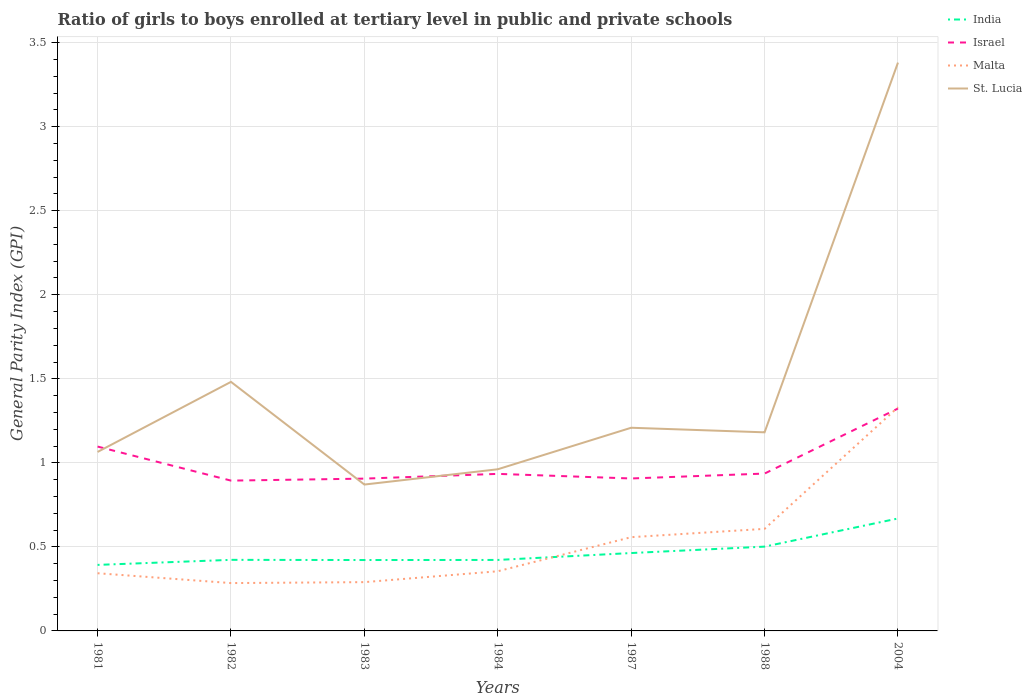How many different coloured lines are there?
Give a very brief answer. 4. Does the line corresponding to India intersect with the line corresponding to Malta?
Keep it short and to the point. Yes. Is the number of lines equal to the number of legend labels?
Your answer should be very brief. Yes. Across all years, what is the maximum general parity index in India?
Your answer should be very brief. 0.39. What is the total general parity index in Malta in the graph?
Offer a very short reply. -0.98. What is the difference between the highest and the second highest general parity index in Israel?
Provide a short and direct response. 0.43. Is the general parity index in Malta strictly greater than the general parity index in Israel over the years?
Your answer should be very brief. No. How many years are there in the graph?
Offer a very short reply. 7. What is the difference between two consecutive major ticks on the Y-axis?
Your answer should be compact. 0.5. Are the values on the major ticks of Y-axis written in scientific E-notation?
Offer a terse response. No. Does the graph contain any zero values?
Your response must be concise. No. Does the graph contain grids?
Give a very brief answer. Yes. What is the title of the graph?
Your response must be concise. Ratio of girls to boys enrolled at tertiary level in public and private schools. Does "Mexico" appear as one of the legend labels in the graph?
Ensure brevity in your answer.  No. What is the label or title of the Y-axis?
Provide a short and direct response. General Parity Index (GPI). What is the General Parity Index (GPI) of India in 1981?
Offer a terse response. 0.39. What is the General Parity Index (GPI) in Israel in 1981?
Your response must be concise. 1.1. What is the General Parity Index (GPI) in Malta in 1981?
Make the answer very short. 0.34. What is the General Parity Index (GPI) in St. Lucia in 1981?
Provide a succinct answer. 1.06. What is the General Parity Index (GPI) in India in 1982?
Provide a succinct answer. 0.42. What is the General Parity Index (GPI) of Israel in 1982?
Give a very brief answer. 0.89. What is the General Parity Index (GPI) in Malta in 1982?
Ensure brevity in your answer.  0.28. What is the General Parity Index (GPI) of St. Lucia in 1982?
Your answer should be very brief. 1.48. What is the General Parity Index (GPI) of India in 1983?
Offer a terse response. 0.42. What is the General Parity Index (GPI) of Israel in 1983?
Your response must be concise. 0.91. What is the General Parity Index (GPI) of Malta in 1983?
Provide a short and direct response. 0.29. What is the General Parity Index (GPI) of St. Lucia in 1983?
Offer a terse response. 0.87. What is the General Parity Index (GPI) in India in 1984?
Give a very brief answer. 0.42. What is the General Parity Index (GPI) in Israel in 1984?
Your answer should be compact. 0.93. What is the General Parity Index (GPI) in Malta in 1984?
Your answer should be compact. 0.35. What is the General Parity Index (GPI) of St. Lucia in 1984?
Keep it short and to the point. 0.96. What is the General Parity Index (GPI) in India in 1987?
Your answer should be very brief. 0.46. What is the General Parity Index (GPI) of Israel in 1987?
Make the answer very short. 0.91. What is the General Parity Index (GPI) of Malta in 1987?
Give a very brief answer. 0.56. What is the General Parity Index (GPI) in St. Lucia in 1987?
Your answer should be very brief. 1.21. What is the General Parity Index (GPI) of India in 1988?
Your response must be concise. 0.5. What is the General Parity Index (GPI) in Israel in 1988?
Your answer should be very brief. 0.94. What is the General Parity Index (GPI) in Malta in 1988?
Give a very brief answer. 0.61. What is the General Parity Index (GPI) in St. Lucia in 1988?
Make the answer very short. 1.18. What is the General Parity Index (GPI) of India in 2004?
Make the answer very short. 0.67. What is the General Parity Index (GPI) of Israel in 2004?
Offer a terse response. 1.32. What is the General Parity Index (GPI) of Malta in 2004?
Give a very brief answer. 1.33. What is the General Parity Index (GPI) of St. Lucia in 2004?
Offer a terse response. 3.38. Across all years, what is the maximum General Parity Index (GPI) in India?
Offer a very short reply. 0.67. Across all years, what is the maximum General Parity Index (GPI) of Israel?
Your answer should be very brief. 1.32. Across all years, what is the maximum General Parity Index (GPI) of Malta?
Your response must be concise. 1.33. Across all years, what is the maximum General Parity Index (GPI) in St. Lucia?
Offer a very short reply. 3.38. Across all years, what is the minimum General Parity Index (GPI) in India?
Ensure brevity in your answer.  0.39. Across all years, what is the minimum General Parity Index (GPI) in Israel?
Your answer should be very brief. 0.89. Across all years, what is the minimum General Parity Index (GPI) of Malta?
Your response must be concise. 0.28. Across all years, what is the minimum General Parity Index (GPI) of St. Lucia?
Keep it short and to the point. 0.87. What is the total General Parity Index (GPI) of India in the graph?
Offer a very short reply. 3.29. What is the total General Parity Index (GPI) in Israel in the graph?
Offer a terse response. 7. What is the total General Parity Index (GPI) in Malta in the graph?
Your answer should be very brief. 3.77. What is the total General Parity Index (GPI) of St. Lucia in the graph?
Ensure brevity in your answer.  10.15. What is the difference between the General Parity Index (GPI) of India in 1981 and that in 1982?
Offer a terse response. -0.03. What is the difference between the General Parity Index (GPI) in Israel in 1981 and that in 1982?
Provide a succinct answer. 0.2. What is the difference between the General Parity Index (GPI) in Malta in 1981 and that in 1982?
Your answer should be very brief. 0.06. What is the difference between the General Parity Index (GPI) of St. Lucia in 1981 and that in 1982?
Ensure brevity in your answer.  -0.42. What is the difference between the General Parity Index (GPI) in India in 1981 and that in 1983?
Offer a very short reply. -0.03. What is the difference between the General Parity Index (GPI) in Israel in 1981 and that in 1983?
Provide a succinct answer. 0.19. What is the difference between the General Parity Index (GPI) of Malta in 1981 and that in 1983?
Your response must be concise. 0.05. What is the difference between the General Parity Index (GPI) in St. Lucia in 1981 and that in 1983?
Provide a short and direct response. 0.19. What is the difference between the General Parity Index (GPI) in India in 1981 and that in 1984?
Offer a terse response. -0.03. What is the difference between the General Parity Index (GPI) of Israel in 1981 and that in 1984?
Your answer should be compact. 0.16. What is the difference between the General Parity Index (GPI) of Malta in 1981 and that in 1984?
Make the answer very short. -0.01. What is the difference between the General Parity Index (GPI) in St. Lucia in 1981 and that in 1984?
Make the answer very short. 0.1. What is the difference between the General Parity Index (GPI) of India in 1981 and that in 1987?
Offer a very short reply. -0.07. What is the difference between the General Parity Index (GPI) of Israel in 1981 and that in 1987?
Offer a terse response. 0.19. What is the difference between the General Parity Index (GPI) in Malta in 1981 and that in 1987?
Make the answer very short. -0.21. What is the difference between the General Parity Index (GPI) in St. Lucia in 1981 and that in 1987?
Keep it short and to the point. -0.14. What is the difference between the General Parity Index (GPI) of India in 1981 and that in 1988?
Ensure brevity in your answer.  -0.11. What is the difference between the General Parity Index (GPI) in Israel in 1981 and that in 1988?
Make the answer very short. 0.16. What is the difference between the General Parity Index (GPI) of Malta in 1981 and that in 1988?
Provide a short and direct response. -0.26. What is the difference between the General Parity Index (GPI) in St. Lucia in 1981 and that in 1988?
Make the answer very short. -0.12. What is the difference between the General Parity Index (GPI) in India in 1981 and that in 2004?
Give a very brief answer. -0.28. What is the difference between the General Parity Index (GPI) of Israel in 1981 and that in 2004?
Make the answer very short. -0.23. What is the difference between the General Parity Index (GPI) of Malta in 1981 and that in 2004?
Keep it short and to the point. -0.99. What is the difference between the General Parity Index (GPI) of St. Lucia in 1981 and that in 2004?
Ensure brevity in your answer.  -2.32. What is the difference between the General Parity Index (GPI) of India in 1982 and that in 1983?
Offer a terse response. 0. What is the difference between the General Parity Index (GPI) of Israel in 1982 and that in 1983?
Your answer should be very brief. -0.01. What is the difference between the General Parity Index (GPI) of Malta in 1982 and that in 1983?
Provide a succinct answer. -0.01. What is the difference between the General Parity Index (GPI) in St. Lucia in 1982 and that in 1983?
Give a very brief answer. 0.61. What is the difference between the General Parity Index (GPI) of India in 1982 and that in 1984?
Your answer should be compact. 0. What is the difference between the General Parity Index (GPI) in Israel in 1982 and that in 1984?
Provide a short and direct response. -0.04. What is the difference between the General Parity Index (GPI) in Malta in 1982 and that in 1984?
Make the answer very short. -0.07. What is the difference between the General Parity Index (GPI) in St. Lucia in 1982 and that in 1984?
Your answer should be compact. 0.52. What is the difference between the General Parity Index (GPI) in India in 1982 and that in 1987?
Your answer should be very brief. -0.04. What is the difference between the General Parity Index (GPI) in Israel in 1982 and that in 1987?
Provide a short and direct response. -0.01. What is the difference between the General Parity Index (GPI) of Malta in 1982 and that in 1987?
Give a very brief answer. -0.27. What is the difference between the General Parity Index (GPI) of St. Lucia in 1982 and that in 1987?
Your answer should be very brief. 0.27. What is the difference between the General Parity Index (GPI) in India in 1982 and that in 1988?
Your answer should be compact. -0.08. What is the difference between the General Parity Index (GPI) in Israel in 1982 and that in 1988?
Offer a terse response. -0.04. What is the difference between the General Parity Index (GPI) of Malta in 1982 and that in 1988?
Ensure brevity in your answer.  -0.32. What is the difference between the General Parity Index (GPI) in St. Lucia in 1982 and that in 1988?
Keep it short and to the point. 0.3. What is the difference between the General Parity Index (GPI) in India in 1982 and that in 2004?
Give a very brief answer. -0.25. What is the difference between the General Parity Index (GPI) in Israel in 1982 and that in 2004?
Your answer should be very brief. -0.43. What is the difference between the General Parity Index (GPI) of Malta in 1982 and that in 2004?
Your answer should be compact. -1.05. What is the difference between the General Parity Index (GPI) of St. Lucia in 1982 and that in 2004?
Provide a short and direct response. -1.9. What is the difference between the General Parity Index (GPI) in India in 1983 and that in 1984?
Make the answer very short. -0. What is the difference between the General Parity Index (GPI) of Israel in 1983 and that in 1984?
Offer a terse response. -0.03. What is the difference between the General Parity Index (GPI) in Malta in 1983 and that in 1984?
Offer a terse response. -0.06. What is the difference between the General Parity Index (GPI) in St. Lucia in 1983 and that in 1984?
Offer a terse response. -0.09. What is the difference between the General Parity Index (GPI) in India in 1983 and that in 1987?
Your answer should be compact. -0.04. What is the difference between the General Parity Index (GPI) of Israel in 1983 and that in 1987?
Give a very brief answer. -0. What is the difference between the General Parity Index (GPI) in Malta in 1983 and that in 1987?
Make the answer very short. -0.27. What is the difference between the General Parity Index (GPI) of St. Lucia in 1983 and that in 1987?
Your answer should be very brief. -0.34. What is the difference between the General Parity Index (GPI) of India in 1983 and that in 1988?
Make the answer very short. -0.08. What is the difference between the General Parity Index (GPI) of Israel in 1983 and that in 1988?
Provide a short and direct response. -0.03. What is the difference between the General Parity Index (GPI) in Malta in 1983 and that in 1988?
Offer a terse response. -0.32. What is the difference between the General Parity Index (GPI) of St. Lucia in 1983 and that in 1988?
Give a very brief answer. -0.31. What is the difference between the General Parity Index (GPI) of India in 1983 and that in 2004?
Your response must be concise. -0.25. What is the difference between the General Parity Index (GPI) of Israel in 1983 and that in 2004?
Keep it short and to the point. -0.42. What is the difference between the General Parity Index (GPI) of Malta in 1983 and that in 2004?
Ensure brevity in your answer.  -1.04. What is the difference between the General Parity Index (GPI) in St. Lucia in 1983 and that in 2004?
Give a very brief answer. -2.51. What is the difference between the General Parity Index (GPI) of India in 1984 and that in 1987?
Ensure brevity in your answer.  -0.04. What is the difference between the General Parity Index (GPI) of Israel in 1984 and that in 1987?
Your answer should be compact. 0.03. What is the difference between the General Parity Index (GPI) in Malta in 1984 and that in 1987?
Your response must be concise. -0.2. What is the difference between the General Parity Index (GPI) in St. Lucia in 1984 and that in 1987?
Give a very brief answer. -0.25. What is the difference between the General Parity Index (GPI) of India in 1984 and that in 1988?
Your answer should be compact. -0.08. What is the difference between the General Parity Index (GPI) in Israel in 1984 and that in 1988?
Provide a succinct answer. -0. What is the difference between the General Parity Index (GPI) in Malta in 1984 and that in 1988?
Ensure brevity in your answer.  -0.25. What is the difference between the General Parity Index (GPI) in St. Lucia in 1984 and that in 1988?
Make the answer very short. -0.22. What is the difference between the General Parity Index (GPI) in India in 1984 and that in 2004?
Keep it short and to the point. -0.25. What is the difference between the General Parity Index (GPI) of Israel in 1984 and that in 2004?
Offer a very short reply. -0.39. What is the difference between the General Parity Index (GPI) in Malta in 1984 and that in 2004?
Your answer should be compact. -0.98. What is the difference between the General Parity Index (GPI) of St. Lucia in 1984 and that in 2004?
Give a very brief answer. -2.42. What is the difference between the General Parity Index (GPI) in India in 1987 and that in 1988?
Your response must be concise. -0.04. What is the difference between the General Parity Index (GPI) in Israel in 1987 and that in 1988?
Provide a succinct answer. -0.03. What is the difference between the General Parity Index (GPI) in Malta in 1987 and that in 1988?
Provide a succinct answer. -0.05. What is the difference between the General Parity Index (GPI) in St. Lucia in 1987 and that in 1988?
Offer a terse response. 0.03. What is the difference between the General Parity Index (GPI) in India in 1987 and that in 2004?
Your answer should be very brief. -0.21. What is the difference between the General Parity Index (GPI) of Israel in 1987 and that in 2004?
Offer a terse response. -0.42. What is the difference between the General Parity Index (GPI) of Malta in 1987 and that in 2004?
Ensure brevity in your answer.  -0.77. What is the difference between the General Parity Index (GPI) of St. Lucia in 1987 and that in 2004?
Your answer should be compact. -2.17. What is the difference between the General Parity Index (GPI) of India in 1988 and that in 2004?
Give a very brief answer. -0.17. What is the difference between the General Parity Index (GPI) of Israel in 1988 and that in 2004?
Your response must be concise. -0.39. What is the difference between the General Parity Index (GPI) of Malta in 1988 and that in 2004?
Offer a very short reply. -0.72. What is the difference between the General Parity Index (GPI) of St. Lucia in 1988 and that in 2004?
Ensure brevity in your answer.  -2.2. What is the difference between the General Parity Index (GPI) of India in 1981 and the General Parity Index (GPI) of Israel in 1982?
Your answer should be very brief. -0.5. What is the difference between the General Parity Index (GPI) of India in 1981 and the General Parity Index (GPI) of Malta in 1982?
Offer a very short reply. 0.11. What is the difference between the General Parity Index (GPI) of India in 1981 and the General Parity Index (GPI) of St. Lucia in 1982?
Offer a very short reply. -1.09. What is the difference between the General Parity Index (GPI) of Israel in 1981 and the General Parity Index (GPI) of Malta in 1982?
Your response must be concise. 0.81. What is the difference between the General Parity Index (GPI) of Israel in 1981 and the General Parity Index (GPI) of St. Lucia in 1982?
Your response must be concise. -0.38. What is the difference between the General Parity Index (GPI) in Malta in 1981 and the General Parity Index (GPI) in St. Lucia in 1982?
Your answer should be very brief. -1.14. What is the difference between the General Parity Index (GPI) in India in 1981 and the General Parity Index (GPI) in Israel in 1983?
Your answer should be very brief. -0.51. What is the difference between the General Parity Index (GPI) in India in 1981 and the General Parity Index (GPI) in Malta in 1983?
Provide a short and direct response. 0.1. What is the difference between the General Parity Index (GPI) in India in 1981 and the General Parity Index (GPI) in St. Lucia in 1983?
Provide a short and direct response. -0.48. What is the difference between the General Parity Index (GPI) in Israel in 1981 and the General Parity Index (GPI) in Malta in 1983?
Keep it short and to the point. 0.81. What is the difference between the General Parity Index (GPI) in Israel in 1981 and the General Parity Index (GPI) in St. Lucia in 1983?
Your answer should be compact. 0.23. What is the difference between the General Parity Index (GPI) in Malta in 1981 and the General Parity Index (GPI) in St. Lucia in 1983?
Your answer should be compact. -0.53. What is the difference between the General Parity Index (GPI) of India in 1981 and the General Parity Index (GPI) of Israel in 1984?
Provide a succinct answer. -0.54. What is the difference between the General Parity Index (GPI) of India in 1981 and the General Parity Index (GPI) of Malta in 1984?
Provide a short and direct response. 0.04. What is the difference between the General Parity Index (GPI) of India in 1981 and the General Parity Index (GPI) of St. Lucia in 1984?
Provide a short and direct response. -0.57. What is the difference between the General Parity Index (GPI) of Israel in 1981 and the General Parity Index (GPI) of Malta in 1984?
Make the answer very short. 0.74. What is the difference between the General Parity Index (GPI) of Israel in 1981 and the General Parity Index (GPI) of St. Lucia in 1984?
Offer a terse response. 0.14. What is the difference between the General Parity Index (GPI) of Malta in 1981 and the General Parity Index (GPI) of St. Lucia in 1984?
Offer a very short reply. -0.62. What is the difference between the General Parity Index (GPI) in India in 1981 and the General Parity Index (GPI) in Israel in 1987?
Your answer should be compact. -0.51. What is the difference between the General Parity Index (GPI) of India in 1981 and the General Parity Index (GPI) of Malta in 1987?
Your answer should be very brief. -0.17. What is the difference between the General Parity Index (GPI) in India in 1981 and the General Parity Index (GPI) in St. Lucia in 1987?
Keep it short and to the point. -0.82. What is the difference between the General Parity Index (GPI) in Israel in 1981 and the General Parity Index (GPI) in Malta in 1987?
Provide a short and direct response. 0.54. What is the difference between the General Parity Index (GPI) of Israel in 1981 and the General Parity Index (GPI) of St. Lucia in 1987?
Your answer should be very brief. -0.11. What is the difference between the General Parity Index (GPI) of Malta in 1981 and the General Parity Index (GPI) of St. Lucia in 1987?
Your answer should be compact. -0.87. What is the difference between the General Parity Index (GPI) of India in 1981 and the General Parity Index (GPI) of Israel in 1988?
Offer a terse response. -0.54. What is the difference between the General Parity Index (GPI) in India in 1981 and the General Parity Index (GPI) in Malta in 1988?
Your answer should be very brief. -0.21. What is the difference between the General Parity Index (GPI) of India in 1981 and the General Parity Index (GPI) of St. Lucia in 1988?
Make the answer very short. -0.79. What is the difference between the General Parity Index (GPI) in Israel in 1981 and the General Parity Index (GPI) in Malta in 1988?
Your answer should be very brief. 0.49. What is the difference between the General Parity Index (GPI) in Israel in 1981 and the General Parity Index (GPI) in St. Lucia in 1988?
Make the answer very short. -0.08. What is the difference between the General Parity Index (GPI) of Malta in 1981 and the General Parity Index (GPI) of St. Lucia in 1988?
Keep it short and to the point. -0.84. What is the difference between the General Parity Index (GPI) of India in 1981 and the General Parity Index (GPI) of Israel in 2004?
Keep it short and to the point. -0.93. What is the difference between the General Parity Index (GPI) in India in 1981 and the General Parity Index (GPI) in Malta in 2004?
Make the answer very short. -0.94. What is the difference between the General Parity Index (GPI) in India in 1981 and the General Parity Index (GPI) in St. Lucia in 2004?
Provide a short and direct response. -2.99. What is the difference between the General Parity Index (GPI) of Israel in 1981 and the General Parity Index (GPI) of Malta in 2004?
Make the answer very short. -0.23. What is the difference between the General Parity Index (GPI) of Israel in 1981 and the General Parity Index (GPI) of St. Lucia in 2004?
Your answer should be compact. -2.28. What is the difference between the General Parity Index (GPI) in Malta in 1981 and the General Parity Index (GPI) in St. Lucia in 2004?
Offer a terse response. -3.04. What is the difference between the General Parity Index (GPI) in India in 1982 and the General Parity Index (GPI) in Israel in 1983?
Give a very brief answer. -0.48. What is the difference between the General Parity Index (GPI) in India in 1982 and the General Parity Index (GPI) in Malta in 1983?
Make the answer very short. 0.13. What is the difference between the General Parity Index (GPI) of India in 1982 and the General Parity Index (GPI) of St. Lucia in 1983?
Provide a succinct answer. -0.45. What is the difference between the General Parity Index (GPI) of Israel in 1982 and the General Parity Index (GPI) of Malta in 1983?
Your response must be concise. 0.6. What is the difference between the General Parity Index (GPI) in Israel in 1982 and the General Parity Index (GPI) in St. Lucia in 1983?
Provide a short and direct response. 0.02. What is the difference between the General Parity Index (GPI) in Malta in 1982 and the General Parity Index (GPI) in St. Lucia in 1983?
Provide a short and direct response. -0.59. What is the difference between the General Parity Index (GPI) of India in 1982 and the General Parity Index (GPI) of Israel in 1984?
Make the answer very short. -0.51. What is the difference between the General Parity Index (GPI) of India in 1982 and the General Parity Index (GPI) of Malta in 1984?
Keep it short and to the point. 0.07. What is the difference between the General Parity Index (GPI) of India in 1982 and the General Parity Index (GPI) of St. Lucia in 1984?
Ensure brevity in your answer.  -0.54. What is the difference between the General Parity Index (GPI) of Israel in 1982 and the General Parity Index (GPI) of Malta in 1984?
Keep it short and to the point. 0.54. What is the difference between the General Parity Index (GPI) in Israel in 1982 and the General Parity Index (GPI) in St. Lucia in 1984?
Provide a short and direct response. -0.07. What is the difference between the General Parity Index (GPI) in Malta in 1982 and the General Parity Index (GPI) in St. Lucia in 1984?
Keep it short and to the point. -0.68. What is the difference between the General Parity Index (GPI) in India in 1982 and the General Parity Index (GPI) in Israel in 1987?
Ensure brevity in your answer.  -0.48. What is the difference between the General Parity Index (GPI) of India in 1982 and the General Parity Index (GPI) of Malta in 1987?
Provide a succinct answer. -0.13. What is the difference between the General Parity Index (GPI) in India in 1982 and the General Parity Index (GPI) in St. Lucia in 1987?
Ensure brevity in your answer.  -0.79. What is the difference between the General Parity Index (GPI) in Israel in 1982 and the General Parity Index (GPI) in Malta in 1987?
Offer a terse response. 0.34. What is the difference between the General Parity Index (GPI) in Israel in 1982 and the General Parity Index (GPI) in St. Lucia in 1987?
Give a very brief answer. -0.31. What is the difference between the General Parity Index (GPI) in Malta in 1982 and the General Parity Index (GPI) in St. Lucia in 1987?
Your answer should be very brief. -0.92. What is the difference between the General Parity Index (GPI) in India in 1982 and the General Parity Index (GPI) in Israel in 1988?
Give a very brief answer. -0.51. What is the difference between the General Parity Index (GPI) in India in 1982 and the General Parity Index (GPI) in Malta in 1988?
Provide a short and direct response. -0.18. What is the difference between the General Parity Index (GPI) of India in 1982 and the General Parity Index (GPI) of St. Lucia in 1988?
Provide a succinct answer. -0.76. What is the difference between the General Parity Index (GPI) in Israel in 1982 and the General Parity Index (GPI) in Malta in 1988?
Give a very brief answer. 0.29. What is the difference between the General Parity Index (GPI) of Israel in 1982 and the General Parity Index (GPI) of St. Lucia in 1988?
Provide a succinct answer. -0.29. What is the difference between the General Parity Index (GPI) in Malta in 1982 and the General Parity Index (GPI) in St. Lucia in 1988?
Keep it short and to the point. -0.9. What is the difference between the General Parity Index (GPI) in India in 1982 and the General Parity Index (GPI) in Israel in 2004?
Give a very brief answer. -0.9. What is the difference between the General Parity Index (GPI) of India in 1982 and the General Parity Index (GPI) of Malta in 2004?
Provide a succinct answer. -0.91. What is the difference between the General Parity Index (GPI) in India in 1982 and the General Parity Index (GPI) in St. Lucia in 2004?
Give a very brief answer. -2.96. What is the difference between the General Parity Index (GPI) in Israel in 1982 and the General Parity Index (GPI) in Malta in 2004?
Provide a succinct answer. -0.44. What is the difference between the General Parity Index (GPI) of Israel in 1982 and the General Parity Index (GPI) of St. Lucia in 2004?
Provide a short and direct response. -2.49. What is the difference between the General Parity Index (GPI) of Malta in 1982 and the General Parity Index (GPI) of St. Lucia in 2004?
Ensure brevity in your answer.  -3.1. What is the difference between the General Parity Index (GPI) of India in 1983 and the General Parity Index (GPI) of Israel in 1984?
Provide a succinct answer. -0.51. What is the difference between the General Parity Index (GPI) of India in 1983 and the General Parity Index (GPI) of Malta in 1984?
Offer a terse response. 0.07. What is the difference between the General Parity Index (GPI) in India in 1983 and the General Parity Index (GPI) in St. Lucia in 1984?
Ensure brevity in your answer.  -0.54. What is the difference between the General Parity Index (GPI) in Israel in 1983 and the General Parity Index (GPI) in Malta in 1984?
Give a very brief answer. 0.55. What is the difference between the General Parity Index (GPI) of Israel in 1983 and the General Parity Index (GPI) of St. Lucia in 1984?
Ensure brevity in your answer.  -0.06. What is the difference between the General Parity Index (GPI) of Malta in 1983 and the General Parity Index (GPI) of St. Lucia in 1984?
Your response must be concise. -0.67. What is the difference between the General Parity Index (GPI) in India in 1983 and the General Parity Index (GPI) in Israel in 1987?
Provide a short and direct response. -0.49. What is the difference between the General Parity Index (GPI) in India in 1983 and the General Parity Index (GPI) in Malta in 1987?
Offer a very short reply. -0.14. What is the difference between the General Parity Index (GPI) of India in 1983 and the General Parity Index (GPI) of St. Lucia in 1987?
Offer a very short reply. -0.79. What is the difference between the General Parity Index (GPI) of Israel in 1983 and the General Parity Index (GPI) of Malta in 1987?
Offer a terse response. 0.35. What is the difference between the General Parity Index (GPI) of Israel in 1983 and the General Parity Index (GPI) of St. Lucia in 1987?
Your answer should be compact. -0.3. What is the difference between the General Parity Index (GPI) of Malta in 1983 and the General Parity Index (GPI) of St. Lucia in 1987?
Keep it short and to the point. -0.92. What is the difference between the General Parity Index (GPI) in India in 1983 and the General Parity Index (GPI) in Israel in 1988?
Provide a short and direct response. -0.51. What is the difference between the General Parity Index (GPI) in India in 1983 and the General Parity Index (GPI) in Malta in 1988?
Ensure brevity in your answer.  -0.19. What is the difference between the General Parity Index (GPI) of India in 1983 and the General Parity Index (GPI) of St. Lucia in 1988?
Give a very brief answer. -0.76. What is the difference between the General Parity Index (GPI) in Israel in 1983 and the General Parity Index (GPI) in Malta in 1988?
Give a very brief answer. 0.3. What is the difference between the General Parity Index (GPI) of Israel in 1983 and the General Parity Index (GPI) of St. Lucia in 1988?
Your response must be concise. -0.28. What is the difference between the General Parity Index (GPI) in Malta in 1983 and the General Parity Index (GPI) in St. Lucia in 1988?
Your answer should be very brief. -0.89. What is the difference between the General Parity Index (GPI) of India in 1983 and the General Parity Index (GPI) of Israel in 2004?
Provide a succinct answer. -0.9. What is the difference between the General Parity Index (GPI) in India in 1983 and the General Parity Index (GPI) in Malta in 2004?
Provide a succinct answer. -0.91. What is the difference between the General Parity Index (GPI) of India in 1983 and the General Parity Index (GPI) of St. Lucia in 2004?
Your answer should be very brief. -2.96. What is the difference between the General Parity Index (GPI) in Israel in 1983 and the General Parity Index (GPI) in Malta in 2004?
Your response must be concise. -0.42. What is the difference between the General Parity Index (GPI) in Israel in 1983 and the General Parity Index (GPI) in St. Lucia in 2004?
Your answer should be compact. -2.48. What is the difference between the General Parity Index (GPI) in Malta in 1983 and the General Parity Index (GPI) in St. Lucia in 2004?
Ensure brevity in your answer.  -3.09. What is the difference between the General Parity Index (GPI) of India in 1984 and the General Parity Index (GPI) of Israel in 1987?
Give a very brief answer. -0.48. What is the difference between the General Parity Index (GPI) of India in 1984 and the General Parity Index (GPI) of Malta in 1987?
Give a very brief answer. -0.14. What is the difference between the General Parity Index (GPI) in India in 1984 and the General Parity Index (GPI) in St. Lucia in 1987?
Provide a short and direct response. -0.79. What is the difference between the General Parity Index (GPI) in Israel in 1984 and the General Parity Index (GPI) in Malta in 1987?
Your answer should be compact. 0.38. What is the difference between the General Parity Index (GPI) of Israel in 1984 and the General Parity Index (GPI) of St. Lucia in 1987?
Ensure brevity in your answer.  -0.27. What is the difference between the General Parity Index (GPI) of Malta in 1984 and the General Parity Index (GPI) of St. Lucia in 1987?
Offer a terse response. -0.85. What is the difference between the General Parity Index (GPI) of India in 1984 and the General Parity Index (GPI) of Israel in 1988?
Provide a succinct answer. -0.51. What is the difference between the General Parity Index (GPI) in India in 1984 and the General Parity Index (GPI) in Malta in 1988?
Provide a short and direct response. -0.18. What is the difference between the General Parity Index (GPI) of India in 1984 and the General Parity Index (GPI) of St. Lucia in 1988?
Offer a terse response. -0.76. What is the difference between the General Parity Index (GPI) of Israel in 1984 and the General Parity Index (GPI) of Malta in 1988?
Provide a succinct answer. 0.33. What is the difference between the General Parity Index (GPI) of Israel in 1984 and the General Parity Index (GPI) of St. Lucia in 1988?
Offer a terse response. -0.25. What is the difference between the General Parity Index (GPI) of Malta in 1984 and the General Parity Index (GPI) of St. Lucia in 1988?
Make the answer very short. -0.83. What is the difference between the General Parity Index (GPI) in India in 1984 and the General Parity Index (GPI) in Israel in 2004?
Make the answer very short. -0.9. What is the difference between the General Parity Index (GPI) of India in 1984 and the General Parity Index (GPI) of Malta in 2004?
Provide a succinct answer. -0.91. What is the difference between the General Parity Index (GPI) in India in 1984 and the General Parity Index (GPI) in St. Lucia in 2004?
Provide a short and direct response. -2.96. What is the difference between the General Parity Index (GPI) of Israel in 1984 and the General Parity Index (GPI) of Malta in 2004?
Provide a short and direct response. -0.4. What is the difference between the General Parity Index (GPI) in Israel in 1984 and the General Parity Index (GPI) in St. Lucia in 2004?
Your answer should be compact. -2.45. What is the difference between the General Parity Index (GPI) of Malta in 1984 and the General Parity Index (GPI) of St. Lucia in 2004?
Provide a succinct answer. -3.03. What is the difference between the General Parity Index (GPI) in India in 1987 and the General Parity Index (GPI) in Israel in 1988?
Provide a succinct answer. -0.47. What is the difference between the General Parity Index (GPI) in India in 1987 and the General Parity Index (GPI) in Malta in 1988?
Provide a succinct answer. -0.14. What is the difference between the General Parity Index (GPI) of India in 1987 and the General Parity Index (GPI) of St. Lucia in 1988?
Your response must be concise. -0.72. What is the difference between the General Parity Index (GPI) in Israel in 1987 and the General Parity Index (GPI) in Malta in 1988?
Offer a terse response. 0.3. What is the difference between the General Parity Index (GPI) of Israel in 1987 and the General Parity Index (GPI) of St. Lucia in 1988?
Keep it short and to the point. -0.27. What is the difference between the General Parity Index (GPI) of Malta in 1987 and the General Parity Index (GPI) of St. Lucia in 1988?
Your response must be concise. -0.62. What is the difference between the General Parity Index (GPI) in India in 1987 and the General Parity Index (GPI) in Israel in 2004?
Offer a terse response. -0.86. What is the difference between the General Parity Index (GPI) in India in 1987 and the General Parity Index (GPI) in Malta in 2004?
Your response must be concise. -0.87. What is the difference between the General Parity Index (GPI) in India in 1987 and the General Parity Index (GPI) in St. Lucia in 2004?
Keep it short and to the point. -2.92. What is the difference between the General Parity Index (GPI) of Israel in 1987 and the General Parity Index (GPI) of Malta in 2004?
Your answer should be compact. -0.42. What is the difference between the General Parity Index (GPI) in Israel in 1987 and the General Parity Index (GPI) in St. Lucia in 2004?
Keep it short and to the point. -2.47. What is the difference between the General Parity Index (GPI) in Malta in 1987 and the General Parity Index (GPI) in St. Lucia in 2004?
Give a very brief answer. -2.82. What is the difference between the General Parity Index (GPI) in India in 1988 and the General Parity Index (GPI) in Israel in 2004?
Your answer should be very brief. -0.82. What is the difference between the General Parity Index (GPI) of India in 1988 and the General Parity Index (GPI) of Malta in 2004?
Make the answer very short. -0.83. What is the difference between the General Parity Index (GPI) of India in 1988 and the General Parity Index (GPI) of St. Lucia in 2004?
Offer a terse response. -2.88. What is the difference between the General Parity Index (GPI) in Israel in 1988 and the General Parity Index (GPI) in Malta in 2004?
Keep it short and to the point. -0.39. What is the difference between the General Parity Index (GPI) in Israel in 1988 and the General Parity Index (GPI) in St. Lucia in 2004?
Offer a terse response. -2.45. What is the difference between the General Parity Index (GPI) of Malta in 1988 and the General Parity Index (GPI) of St. Lucia in 2004?
Offer a terse response. -2.77. What is the average General Parity Index (GPI) in India per year?
Ensure brevity in your answer.  0.47. What is the average General Parity Index (GPI) of Malta per year?
Keep it short and to the point. 0.54. What is the average General Parity Index (GPI) in St. Lucia per year?
Give a very brief answer. 1.45. In the year 1981, what is the difference between the General Parity Index (GPI) of India and General Parity Index (GPI) of Israel?
Give a very brief answer. -0.7. In the year 1981, what is the difference between the General Parity Index (GPI) of India and General Parity Index (GPI) of Malta?
Provide a succinct answer. 0.05. In the year 1981, what is the difference between the General Parity Index (GPI) in India and General Parity Index (GPI) in St. Lucia?
Give a very brief answer. -0.67. In the year 1981, what is the difference between the General Parity Index (GPI) in Israel and General Parity Index (GPI) in Malta?
Provide a short and direct response. 0.75. In the year 1981, what is the difference between the General Parity Index (GPI) of Israel and General Parity Index (GPI) of St. Lucia?
Offer a terse response. 0.03. In the year 1981, what is the difference between the General Parity Index (GPI) in Malta and General Parity Index (GPI) in St. Lucia?
Offer a terse response. -0.72. In the year 1982, what is the difference between the General Parity Index (GPI) of India and General Parity Index (GPI) of Israel?
Your answer should be compact. -0.47. In the year 1982, what is the difference between the General Parity Index (GPI) in India and General Parity Index (GPI) in Malta?
Give a very brief answer. 0.14. In the year 1982, what is the difference between the General Parity Index (GPI) in India and General Parity Index (GPI) in St. Lucia?
Offer a very short reply. -1.06. In the year 1982, what is the difference between the General Parity Index (GPI) in Israel and General Parity Index (GPI) in Malta?
Give a very brief answer. 0.61. In the year 1982, what is the difference between the General Parity Index (GPI) in Israel and General Parity Index (GPI) in St. Lucia?
Your answer should be compact. -0.59. In the year 1982, what is the difference between the General Parity Index (GPI) in Malta and General Parity Index (GPI) in St. Lucia?
Make the answer very short. -1.2. In the year 1983, what is the difference between the General Parity Index (GPI) in India and General Parity Index (GPI) in Israel?
Your response must be concise. -0.48. In the year 1983, what is the difference between the General Parity Index (GPI) in India and General Parity Index (GPI) in Malta?
Make the answer very short. 0.13. In the year 1983, what is the difference between the General Parity Index (GPI) of India and General Parity Index (GPI) of St. Lucia?
Offer a terse response. -0.45. In the year 1983, what is the difference between the General Parity Index (GPI) of Israel and General Parity Index (GPI) of Malta?
Your response must be concise. 0.62. In the year 1983, what is the difference between the General Parity Index (GPI) in Israel and General Parity Index (GPI) in St. Lucia?
Offer a very short reply. 0.04. In the year 1983, what is the difference between the General Parity Index (GPI) of Malta and General Parity Index (GPI) of St. Lucia?
Your answer should be very brief. -0.58. In the year 1984, what is the difference between the General Parity Index (GPI) in India and General Parity Index (GPI) in Israel?
Your answer should be very brief. -0.51. In the year 1984, what is the difference between the General Parity Index (GPI) in India and General Parity Index (GPI) in Malta?
Your answer should be very brief. 0.07. In the year 1984, what is the difference between the General Parity Index (GPI) in India and General Parity Index (GPI) in St. Lucia?
Provide a succinct answer. -0.54. In the year 1984, what is the difference between the General Parity Index (GPI) of Israel and General Parity Index (GPI) of Malta?
Offer a very short reply. 0.58. In the year 1984, what is the difference between the General Parity Index (GPI) in Israel and General Parity Index (GPI) in St. Lucia?
Offer a very short reply. -0.03. In the year 1984, what is the difference between the General Parity Index (GPI) of Malta and General Parity Index (GPI) of St. Lucia?
Offer a terse response. -0.61. In the year 1987, what is the difference between the General Parity Index (GPI) in India and General Parity Index (GPI) in Israel?
Ensure brevity in your answer.  -0.44. In the year 1987, what is the difference between the General Parity Index (GPI) in India and General Parity Index (GPI) in Malta?
Your answer should be compact. -0.09. In the year 1987, what is the difference between the General Parity Index (GPI) in India and General Parity Index (GPI) in St. Lucia?
Provide a short and direct response. -0.75. In the year 1987, what is the difference between the General Parity Index (GPI) of Israel and General Parity Index (GPI) of Malta?
Your answer should be very brief. 0.35. In the year 1987, what is the difference between the General Parity Index (GPI) of Israel and General Parity Index (GPI) of St. Lucia?
Keep it short and to the point. -0.3. In the year 1987, what is the difference between the General Parity Index (GPI) of Malta and General Parity Index (GPI) of St. Lucia?
Your answer should be compact. -0.65. In the year 1988, what is the difference between the General Parity Index (GPI) of India and General Parity Index (GPI) of Israel?
Offer a terse response. -0.43. In the year 1988, what is the difference between the General Parity Index (GPI) of India and General Parity Index (GPI) of Malta?
Provide a short and direct response. -0.11. In the year 1988, what is the difference between the General Parity Index (GPI) of India and General Parity Index (GPI) of St. Lucia?
Ensure brevity in your answer.  -0.68. In the year 1988, what is the difference between the General Parity Index (GPI) of Israel and General Parity Index (GPI) of Malta?
Your response must be concise. 0.33. In the year 1988, what is the difference between the General Parity Index (GPI) of Israel and General Parity Index (GPI) of St. Lucia?
Your response must be concise. -0.25. In the year 1988, what is the difference between the General Parity Index (GPI) in Malta and General Parity Index (GPI) in St. Lucia?
Make the answer very short. -0.57. In the year 2004, what is the difference between the General Parity Index (GPI) of India and General Parity Index (GPI) of Israel?
Give a very brief answer. -0.65. In the year 2004, what is the difference between the General Parity Index (GPI) in India and General Parity Index (GPI) in Malta?
Your response must be concise. -0.66. In the year 2004, what is the difference between the General Parity Index (GPI) in India and General Parity Index (GPI) in St. Lucia?
Your response must be concise. -2.71. In the year 2004, what is the difference between the General Parity Index (GPI) in Israel and General Parity Index (GPI) in Malta?
Your response must be concise. -0.01. In the year 2004, what is the difference between the General Parity Index (GPI) of Israel and General Parity Index (GPI) of St. Lucia?
Provide a succinct answer. -2.06. In the year 2004, what is the difference between the General Parity Index (GPI) in Malta and General Parity Index (GPI) in St. Lucia?
Provide a short and direct response. -2.05. What is the ratio of the General Parity Index (GPI) of India in 1981 to that in 1982?
Your response must be concise. 0.93. What is the ratio of the General Parity Index (GPI) of Israel in 1981 to that in 1982?
Your answer should be compact. 1.23. What is the ratio of the General Parity Index (GPI) of Malta in 1981 to that in 1982?
Give a very brief answer. 1.21. What is the ratio of the General Parity Index (GPI) of St. Lucia in 1981 to that in 1982?
Offer a terse response. 0.72. What is the ratio of the General Parity Index (GPI) in India in 1981 to that in 1983?
Ensure brevity in your answer.  0.93. What is the ratio of the General Parity Index (GPI) of Israel in 1981 to that in 1983?
Your answer should be compact. 1.21. What is the ratio of the General Parity Index (GPI) of Malta in 1981 to that in 1983?
Your answer should be compact. 1.18. What is the ratio of the General Parity Index (GPI) of St. Lucia in 1981 to that in 1983?
Offer a very short reply. 1.22. What is the ratio of the General Parity Index (GPI) of India in 1981 to that in 1984?
Your response must be concise. 0.93. What is the ratio of the General Parity Index (GPI) in Israel in 1981 to that in 1984?
Your response must be concise. 1.17. What is the ratio of the General Parity Index (GPI) of Malta in 1981 to that in 1984?
Ensure brevity in your answer.  0.97. What is the ratio of the General Parity Index (GPI) of St. Lucia in 1981 to that in 1984?
Your answer should be compact. 1.11. What is the ratio of the General Parity Index (GPI) in India in 1981 to that in 1987?
Make the answer very short. 0.85. What is the ratio of the General Parity Index (GPI) in Israel in 1981 to that in 1987?
Provide a short and direct response. 1.21. What is the ratio of the General Parity Index (GPI) of Malta in 1981 to that in 1987?
Your response must be concise. 0.62. What is the ratio of the General Parity Index (GPI) in St. Lucia in 1981 to that in 1987?
Make the answer very short. 0.88. What is the ratio of the General Parity Index (GPI) of India in 1981 to that in 1988?
Ensure brevity in your answer.  0.78. What is the ratio of the General Parity Index (GPI) in Israel in 1981 to that in 1988?
Ensure brevity in your answer.  1.17. What is the ratio of the General Parity Index (GPI) of Malta in 1981 to that in 1988?
Make the answer very short. 0.57. What is the ratio of the General Parity Index (GPI) in St. Lucia in 1981 to that in 1988?
Offer a terse response. 0.9. What is the ratio of the General Parity Index (GPI) of India in 1981 to that in 2004?
Your answer should be compact. 0.59. What is the ratio of the General Parity Index (GPI) of Israel in 1981 to that in 2004?
Your answer should be very brief. 0.83. What is the ratio of the General Parity Index (GPI) of Malta in 1981 to that in 2004?
Keep it short and to the point. 0.26. What is the ratio of the General Parity Index (GPI) in St. Lucia in 1981 to that in 2004?
Ensure brevity in your answer.  0.31. What is the ratio of the General Parity Index (GPI) in Israel in 1982 to that in 1983?
Your response must be concise. 0.99. What is the ratio of the General Parity Index (GPI) in Malta in 1982 to that in 1983?
Your answer should be compact. 0.98. What is the ratio of the General Parity Index (GPI) in St. Lucia in 1982 to that in 1983?
Ensure brevity in your answer.  1.7. What is the ratio of the General Parity Index (GPI) of Israel in 1982 to that in 1984?
Offer a very short reply. 0.96. What is the ratio of the General Parity Index (GPI) of Malta in 1982 to that in 1984?
Offer a very short reply. 0.8. What is the ratio of the General Parity Index (GPI) of St. Lucia in 1982 to that in 1984?
Provide a short and direct response. 1.54. What is the ratio of the General Parity Index (GPI) of India in 1982 to that in 1987?
Provide a short and direct response. 0.91. What is the ratio of the General Parity Index (GPI) of Israel in 1982 to that in 1987?
Your response must be concise. 0.99. What is the ratio of the General Parity Index (GPI) of Malta in 1982 to that in 1987?
Ensure brevity in your answer.  0.51. What is the ratio of the General Parity Index (GPI) of St. Lucia in 1982 to that in 1987?
Your answer should be very brief. 1.23. What is the ratio of the General Parity Index (GPI) in India in 1982 to that in 1988?
Keep it short and to the point. 0.84. What is the ratio of the General Parity Index (GPI) in Israel in 1982 to that in 1988?
Make the answer very short. 0.96. What is the ratio of the General Parity Index (GPI) in Malta in 1982 to that in 1988?
Provide a short and direct response. 0.47. What is the ratio of the General Parity Index (GPI) of St. Lucia in 1982 to that in 1988?
Make the answer very short. 1.25. What is the ratio of the General Parity Index (GPI) of India in 1982 to that in 2004?
Your answer should be very brief. 0.63. What is the ratio of the General Parity Index (GPI) of Israel in 1982 to that in 2004?
Your answer should be very brief. 0.68. What is the ratio of the General Parity Index (GPI) of Malta in 1982 to that in 2004?
Keep it short and to the point. 0.21. What is the ratio of the General Parity Index (GPI) in St. Lucia in 1982 to that in 2004?
Offer a terse response. 0.44. What is the ratio of the General Parity Index (GPI) of India in 1983 to that in 1984?
Offer a very short reply. 1. What is the ratio of the General Parity Index (GPI) in Israel in 1983 to that in 1984?
Your answer should be compact. 0.97. What is the ratio of the General Parity Index (GPI) in Malta in 1983 to that in 1984?
Your answer should be very brief. 0.82. What is the ratio of the General Parity Index (GPI) of St. Lucia in 1983 to that in 1984?
Keep it short and to the point. 0.91. What is the ratio of the General Parity Index (GPI) in India in 1983 to that in 1987?
Your response must be concise. 0.91. What is the ratio of the General Parity Index (GPI) in Israel in 1983 to that in 1987?
Provide a succinct answer. 1. What is the ratio of the General Parity Index (GPI) of Malta in 1983 to that in 1987?
Give a very brief answer. 0.52. What is the ratio of the General Parity Index (GPI) in St. Lucia in 1983 to that in 1987?
Provide a short and direct response. 0.72. What is the ratio of the General Parity Index (GPI) of India in 1983 to that in 1988?
Provide a short and direct response. 0.84. What is the ratio of the General Parity Index (GPI) of Malta in 1983 to that in 1988?
Give a very brief answer. 0.48. What is the ratio of the General Parity Index (GPI) in St. Lucia in 1983 to that in 1988?
Your answer should be very brief. 0.74. What is the ratio of the General Parity Index (GPI) of India in 1983 to that in 2004?
Your answer should be compact. 0.63. What is the ratio of the General Parity Index (GPI) in Israel in 1983 to that in 2004?
Offer a very short reply. 0.68. What is the ratio of the General Parity Index (GPI) of Malta in 1983 to that in 2004?
Offer a very short reply. 0.22. What is the ratio of the General Parity Index (GPI) of St. Lucia in 1983 to that in 2004?
Ensure brevity in your answer.  0.26. What is the ratio of the General Parity Index (GPI) in India in 1984 to that in 1987?
Offer a terse response. 0.91. What is the ratio of the General Parity Index (GPI) in Israel in 1984 to that in 1987?
Ensure brevity in your answer.  1.03. What is the ratio of the General Parity Index (GPI) in Malta in 1984 to that in 1987?
Your answer should be compact. 0.64. What is the ratio of the General Parity Index (GPI) in St. Lucia in 1984 to that in 1987?
Make the answer very short. 0.8. What is the ratio of the General Parity Index (GPI) of India in 1984 to that in 1988?
Provide a short and direct response. 0.84. What is the ratio of the General Parity Index (GPI) in Malta in 1984 to that in 1988?
Your answer should be compact. 0.58. What is the ratio of the General Parity Index (GPI) of St. Lucia in 1984 to that in 1988?
Give a very brief answer. 0.81. What is the ratio of the General Parity Index (GPI) in India in 1984 to that in 2004?
Your answer should be compact. 0.63. What is the ratio of the General Parity Index (GPI) in Israel in 1984 to that in 2004?
Offer a very short reply. 0.71. What is the ratio of the General Parity Index (GPI) of Malta in 1984 to that in 2004?
Your answer should be very brief. 0.27. What is the ratio of the General Parity Index (GPI) in St. Lucia in 1984 to that in 2004?
Offer a very short reply. 0.28. What is the ratio of the General Parity Index (GPI) in India in 1987 to that in 1988?
Ensure brevity in your answer.  0.92. What is the ratio of the General Parity Index (GPI) in Israel in 1987 to that in 1988?
Your answer should be very brief. 0.97. What is the ratio of the General Parity Index (GPI) of Malta in 1987 to that in 1988?
Your answer should be very brief. 0.92. What is the ratio of the General Parity Index (GPI) in India in 1987 to that in 2004?
Your answer should be very brief. 0.69. What is the ratio of the General Parity Index (GPI) of Israel in 1987 to that in 2004?
Make the answer very short. 0.69. What is the ratio of the General Parity Index (GPI) in Malta in 1987 to that in 2004?
Your answer should be compact. 0.42. What is the ratio of the General Parity Index (GPI) in St. Lucia in 1987 to that in 2004?
Your response must be concise. 0.36. What is the ratio of the General Parity Index (GPI) of India in 1988 to that in 2004?
Your answer should be compact. 0.75. What is the ratio of the General Parity Index (GPI) of Israel in 1988 to that in 2004?
Provide a succinct answer. 0.71. What is the ratio of the General Parity Index (GPI) in Malta in 1988 to that in 2004?
Offer a very short reply. 0.46. What is the ratio of the General Parity Index (GPI) of St. Lucia in 1988 to that in 2004?
Your answer should be compact. 0.35. What is the difference between the highest and the second highest General Parity Index (GPI) of India?
Offer a terse response. 0.17. What is the difference between the highest and the second highest General Parity Index (GPI) of Israel?
Your response must be concise. 0.23. What is the difference between the highest and the second highest General Parity Index (GPI) of Malta?
Your answer should be compact. 0.72. What is the difference between the highest and the second highest General Parity Index (GPI) in St. Lucia?
Offer a terse response. 1.9. What is the difference between the highest and the lowest General Parity Index (GPI) in India?
Make the answer very short. 0.28. What is the difference between the highest and the lowest General Parity Index (GPI) in Israel?
Your answer should be very brief. 0.43. What is the difference between the highest and the lowest General Parity Index (GPI) in Malta?
Make the answer very short. 1.05. What is the difference between the highest and the lowest General Parity Index (GPI) in St. Lucia?
Provide a short and direct response. 2.51. 